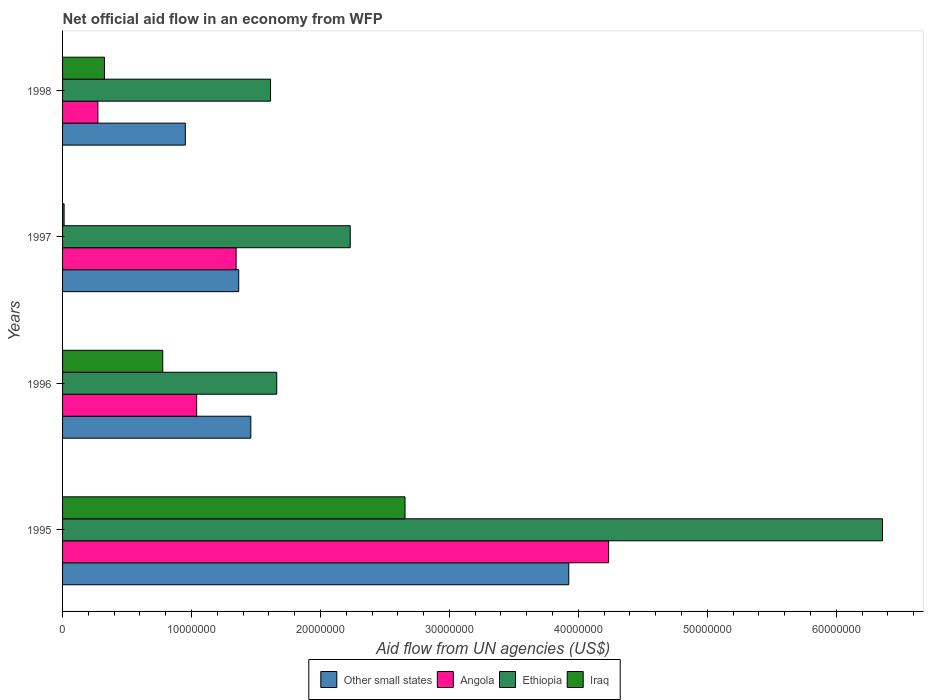How many different coloured bars are there?
Offer a terse response. 4. How many groups of bars are there?
Your answer should be very brief. 4. How many bars are there on the 2nd tick from the bottom?
Keep it short and to the point. 4. What is the label of the 2nd group of bars from the top?
Your answer should be very brief. 1997. What is the net official aid flow in Angola in 1997?
Offer a very short reply. 1.35e+07. Across all years, what is the maximum net official aid flow in Iraq?
Offer a very short reply. 2.66e+07. Across all years, what is the minimum net official aid flow in Angola?
Offer a very short reply. 2.74e+06. In which year was the net official aid flow in Other small states minimum?
Your response must be concise. 1998. What is the total net official aid flow in Iraq in the graph?
Keep it short and to the point. 3.77e+07. What is the difference between the net official aid flow in Angola in 1996 and that in 1998?
Provide a short and direct response. 7.66e+06. What is the difference between the net official aid flow in Ethiopia in 1996 and the net official aid flow in Other small states in 1998?
Provide a short and direct response. 7.09e+06. What is the average net official aid flow in Ethiopia per year?
Offer a very short reply. 2.97e+07. In the year 1996, what is the difference between the net official aid flow in Iraq and net official aid flow in Angola?
Keep it short and to the point. -2.63e+06. In how many years, is the net official aid flow in Other small states greater than 62000000 US$?
Offer a very short reply. 0. What is the ratio of the net official aid flow in Angola in 1996 to that in 1997?
Your answer should be very brief. 0.77. Is the difference between the net official aid flow in Iraq in 1995 and 1997 greater than the difference between the net official aid flow in Angola in 1995 and 1997?
Provide a short and direct response. No. What is the difference between the highest and the second highest net official aid flow in Ethiopia?
Ensure brevity in your answer.  4.13e+07. What is the difference between the highest and the lowest net official aid flow in Iraq?
Keep it short and to the point. 2.64e+07. In how many years, is the net official aid flow in Ethiopia greater than the average net official aid flow in Ethiopia taken over all years?
Your response must be concise. 1. Is the sum of the net official aid flow in Iraq in 1996 and 1998 greater than the maximum net official aid flow in Ethiopia across all years?
Keep it short and to the point. No. What does the 1st bar from the top in 1995 represents?
Provide a succinct answer. Iraq. What does the 2nd bar from the bottom in 1996 represents?
Your answer should be compact. Angola. Is it the case that in every year, the sum of the net official aid flow in Other small states and net official aid flow in Angola is greater than the net official aid flow in Iraq?
Offer a very short reply. Yes. How many bars are there?
Ensure brevity in your answer.  16. Are all the bars in the graph horizontal?
Offer a very short reply. Yes. Are the values on the major ticks of X-axis written in scientific E-notation?
Keep it short and to the point. No. How are the legend labels stacked?
Keep it short and to the point. Horizontal. What is the title of the graph?
Provide a succinct answer. Net official aid flow in an economy from WFP. Does "Middle East & North Africa (all income levels)" appear as one of the legend labels in the graph?
Offer a terse response. No. What is the label or title of the X-axis?
Your answer should be very brief. Aid flow from UN agencies (US$). What is the label or title of the Y-axis?
Offer a terse response. Years. What is the Aid flow from UN agencies (US$) of Other small states in 1995?
Offer a very short reply. 3.93e+07. What is the Aid flow from UN agencies (US$) of Angola in 1995?
Offer a terse response. 4.24e+07. What is the Aid flow from UN agencies (US$) in Ethiopia in 1995?
Provide a short and direct response. 6.36e+07. What is the Aid flow from UN agencies (US$) in Iraq in 1995?
Offer a very short reply. 2.66e+07. What is the Aid flow from UN agencies (US$) of Other small states in 1996?
Your answer should be very brief. 1.46e+07. What is the Aid flow from UN agencies (US$) in Angola in 1996?
Provide a short and direct response. 1.04e+07. What is the Aid flow from UN agencies (US$) in Ethiopia in 1996?
Provide a succinct answer. 1.66e+07. What is the Aid flow from UN agencies (US$) of Iraq in 1996?
Your answer should be very brief. 7.77e+06. What is the Aid flow from UN agencies (US$) in Other small states in 1997?
Offer a terse response. 1.37e+07. What is the Aid flow from UN agencies (US$) of Angola in 1997?
Provide a succinct answer. 1.35e+07. What is the Aid flow from UN agencies (US$) in Ethiopia in 1997?
Keep it short and to the point. 2.23e+07. What is the Aid flow from UN agencies (US$) of Other small states in 1998?
Your response must be concise. 9.52e+06. What is the Aid flow from UN agencies (US$) of Angola in 1998?
Provide a short and direct response. 2.74e+06. What is the Aid flow from UN agencies (US$) in Ethiopia in 1998?
Make the answer very short. 1.61e+07. What is the Aid flow from UN agencies (US$) of Iraq in 1998?
Your response must be concise. 3.25e+06. Across all years, what is the maximum Aid flow from UN agencies (US$) of Other small states?
Your answer should be very brief. 3.93e+07. Across all years, what is the maximum Aid flow from UN agencies (US$) of Angola?
Give a very brief answer. 4.24e+07. Across all years, what is the maximum Aid flow from UN agencies (US$) of Ethiopia?
Offer a terse response. 6.36e+07. Across all years, what is the maximum Aid flow from UN agencies (US$) of Iraq?
Ensure brevity in your answer.  2.66e+07. Across all years, what is the minimum Aid flow from UN agencies (US$) in Other small states?
Keep it short and to the point. 9.52e+06. Across all years, what is the minimum Aid flow from UN agencies (US$) of Angola?
Give a very brief answer. 2.74e+06. Across all years, what is the minimum Aid flow from UN agencies (US$) of Ethiopia?
Give a very brief answer. 1.61e+07. Across all years, what is the minimum Aid flow from UN agencies (US$) in Iraq?
Ensure brevity in your answer.  1.20e+05. What is the total Aid flow from UN agencies (US$) in Other small states in the graph?
Provide a succinct answer. 7.70e+07. What is the total Aid flow from UN agencies (US$) in Angola in the graph?
Make the answer very short. 6.90e+07. What is the total Aid flow from UN agencies (US$) in Ethiopia in the graph?
Keep it short and to the point. 1.19e+08. What is the total Aid flow from UN agencies (US$) in Iraq in the graph?
Provide a succinct answer. 3.77e+07. What is the difference between the Aid flow from UN agencies (US$) in Other small states in 1995 and that in 1996?
Offer a terse response. 2.47e+07. What is the difference between the Aid flow from UN agencies (US$) in Angola in 1995 and that in 1996?
Make the answer very short. 3.20e+07. What is the difference between the Aid flow from UN agencies (US$) in Ethiopia in 1995 and that in 1996?
Your answer should be compact. 4.70e+07. What is the difference between the Aid flow from UN agencies (US$) of Iraq in 1995 and that in 1996?
Ensure brevity in your answer.  1.88e+07. What is the difference between the Aid flow from UN agencies (US$) of Other small states in 1995 and that in 1997?
Provide a short and direct response. 2.56e+07. What is the difference between the Aid flow from UN agencies (US$) in Angola in 1995 and that in 1997?
Provide a succinct answer. 2.89e+07. What is the difference between the Aid flow from UN agencies (US$) in Ethiopia in 1995 and that in 1997?
Provide a succinct answer. 4.13e+07. What is the difference between the Aid flow from UN agencies (US$) in Iraq in 1995 and that in 1997?
Your answer should be compact. 2.64e+07. What is the difference between the Aid flow from UN agencies (US$) in Other small states in 1995 and that in 1998?
Give a very brief answer. 2.97e+07. What is the difference between the Aid flow from UN agencies (US$) in Angola in 1995 and that in 1998?
Ensure brevity in your answer.  3.96e+07. What is the difference between the Aid flow from UN agencies (US$) of Ethiopia in 1995 and that in 1998?
Your answer should be compact. 4.75e+07. What is the difference between the Aid flow from UN agencies (US$) of Iraq in 1995 and that in 1998?
Make the answer very short. 2.33e+07. What is the difference between the Aid flow from UN agencies (US$) of Other small states in 1996 and that in 1997?
Provide a succinct answer. 9.40e+05. What is the difference between the Aid flow from UN agencies (US$) of Angola in 1996 and that in 1997?
Offer a very short reply. -3.06e+06. What is the difference between the Aid flow from UN agencies (US$) of Ethiopia in 1996 and that in 1997?
Provide a succinct answer. -5.70e+06. What is the difference between the Aid flow from UN agencies (US$) of Iraq in 1996 and that in 1997?
Provide a succinct answer. 7.65e+06. What is the difference between the Aid flow from UN agencies (US$) of Other small states in 1996 and that in 1998?
Make the answer very short. 5.08e+06. What is the difference between the Aid flow from UN agencies (US$) of Angola in 1996 and that in 1998?
Make the answer very short. 7.66e+06. What is the difference between the Aid flow from UN agencies (US$) of Ethiopia in 1996 and that in 1998?
Offer a very short reply. 4.80e+05. What is the difference between the Aid flow from UN agencies (US$) in Iraq in 1996 and that in 1998?
Offer a terse response. 4.52e+06. What is the difference between the Aid flow from UN agencies (US$) of Other small states in 1997 and that in 1998?
Your response must be concise. 4.14e+06. What is the difference between the Aid flow from UN agencies (US$) of Angola in 1997 and that in 1998?
Ensure brevity in your answer.  1.07e+07. What is the difference between the Aid flow from UN agencies (US$) of Ethiopia in 1997 and that in 1998?
Offer a terse response. 6.18e+06. What is the difference between the Aid flow from UN agencies (US$) in Iraq in 1997 and that in 1998?
Provide a succinct answer. -3.13e+06. What is the difference between the Aid flow from UN agencies (US$) of Other small states in 1995 and the Aid flow from UN agencies (US$) of Angola in 1996?
Your answer should be compact. 2.89e+07. What is the difference between the Aid flow from UN agencies (US$) of Other small states in 1995 and the Aid flow from UN agencies (US$) of Ethiopia in 1996?
Your answer should be compact. 2.26e+07. What is the difference between the Aid flow from UN agencies (US$) of Other small states in 1995 and the Aid flow from UN agencies (US$) of Iraq in 1996?
Give a very brief answer. 3.15e+07. What is the difference between the Aid flow from UN agencies (US$) in Angola in 1995 and the Aid flow from UN agencies (US$) in Ethiopia in 1996?
Your response must be concise. 2.57e+07. What is the difference between the Aid flow from UN agencies (US$) in Angola in 1995 and the Aid flow from UN agencies (US$) in Iraq in 1996?
Provide a succinct answer. 3.46e+07. What is the difference between the Aid flow from UN agencies (US$) of Ethiopia in 1995 and the Aid flow from UN agencies (US$) of Iraq in 1996?
Offer a very short reply. 5.58e+07. What is the difference between the Aid flow from UN agencies (US$) of Other small states in 1995 and the Aid flow from UN agencies (US$) of Angola in 1997?
Offer a very short reply. 2.58e+07. What is the difference between the Aid flow from UN agencies (US$) in Other small states in 1995 and the Aid flow from UN agencies (US$) in Ethiopia in 1997?
Your response must be concise. 1.70e+07. What is the difference between the Aid flow from UN agencies (US$) of Other small states in 1995 and the Aid flow from UN agencies (US$) of Iraq in 1997?
Offer a very short reply. 3.91e+07. What is the difference between the Aid flow from UN agencies (US$) in Angola in 1995 and the Aid flow from UN agencies (US$) in Ethiopia in 1997?
Make the answer very short. 2.00e+07. What is the difference between the Aid flow from UN agencies (US$) in Angola in 1995 and the Aid flow from UN agencies (US$) in Iraq in 1997?
Offer a very short reply. 4.22e+07. What is the difference between the Aid flow from UN agencies (US$) in Ethiopia in 1995 and the Aid flow from UN agencies (US$) in Iraq in 1997?
Provide a succinct answer. 6.35e+07. What is the difference between the Aid flow from UN agencies (US$) in Other small states in 1995 and the Aid flow from UN agencies (US$) in Angola in 1998?
Offer a very short reply. 3.65e+07. What is the difference between the Aid flow from UN agencies (US$) in Other small states in 1995 and the Aid flow from UN agencies (US$) in Ethiopia in 1998?
Give a very brief answer. 2.31e+07. What is the difference between the Aid flow from UN agencies (US$) in Other small states in 1995 and the Aid flow from UN agencies (US$) in Iraq in 1998?
Make the answer very short. 3.60e+07. What is the difference between the Aid flow from UN agencies (US$) of Angola in 1995 and the Aid flow from UN agencies (US$) of Ethiopia in 1998?
Provide a short and direct response. 2.62e+07. What is the difference between the Aid flow from UN agencies (US$) of Angola in 1995 and the Aid flow from UN agencies (US$) of Iraq in 1998?
Your answer should be compact. 3.91e+07. What is the difference between the Aid flow from UN agencies (US$) in Ethiopia in 1995 and the Aid flow from UN agencies (US$) in Iraq in 1998?
Ensure brevity in your answer.  6.03e+07. What is the difference between the Aid flow from UN agencies (US$) of Other small states in 1996 and the Aid flow from UN agencies (US$) of Angola in 1997?
Ensure brevity in your answer.  1.14e+06. What is the difference between the Aid flow from UN agencies (US$) of Other small states in 1996 and the Aid flow from UN agencies (US$) of Ethiopia in 1997?
Keep it short and to the point. -7.71e+06. What is the difference between the Aid flow from UN agencies (US$) in Other small states in 1996 and the Aid flow from UN agencies (US$) in Iraq in 1997?
Ensure brevity in your answer.  1.45e+07. What is the difference between the Aid flow from UN agencies (US$) in Angola in 1996 and the Aid flow from UN agencies (US$) in Ethiopia in 1997?
Make the answer very short. -1.19e+07. What is the difference between the Aid flow from UN agencies (US$) of Angola in 1996 and the Aid flow from UN agencies (US$) of Iraq in 1997?
Provide a succinct answer. 1.03e+07. What is the difference between the Aid flow from UN agencies (US$) of Ethiopia in 1996 and the Aid flow from UN agencies (US$) of Iraq in 1997?
Your response must be concise. 1.65e+07. What is the difference between the Aid flow from UN agencies (US$) in Other small states in 1996 and the Aid flow from UN agencies (US$) in Angola in 1998?
Give a very brief answer. 1.19e+07. What is the difference between the Aid flow from UN agencies (US$) of Other small states in 1996 and the Aid flow from UN agencies (US$) of Ethiopia in 1998?
Your response must be concise. -1.53e+06. What is the difference between the Aid flow from UN agencies (US$) in Other small states in 1996 and the Aid flow from UN agencies (US$) in Iraq in 1998?
Provide a short and direct response. 1.14e+07. What is the difference between the Aid flow from UN agencies (US$) of Angola in 1996 and the Aid flow from UN agencies (US$) of Ethiopia in 1998?
Your answer should be compact. -5.73e+06. What is the difference between the Aid flow from UN agencies (US$) of Angola in 1996 and the Aid flow from UN agencies (US$) of Iraq in 1998?
Offer a very short reply. 7.15e+06. What is the difference between the Aid flow from UN agencies (US$) in Ethiopia in 1996 and the Aid flow from UN agencies (US$) in Iraq in 1998?
Ensure brevity in your answer.  1.34e+07. What is the difference between the Aid flow from UN agencies (US$) of Other small states in 1997 and the Aid flow from UN agencies (US$) of Angola in 1998?
Give a very brief answer. 1.09e+07. What is the difference between the Aid flow from UN agencies (US$) in Other small states in 1997 and the Aid flow from UN agencies (US$) in Ethiopia in 1998?
Your answer should be compact. -2.47e+06. What is the difference between the Aid flow from UN agencies (US$) of Other small states in 1997 and the Aid flow from UN agencies (US$) of Iraq in 1998?
Make the answer very short. 1.04e+07. What is the difference between the Aid flow from UN agencies (US$) in Angola in 1997 and the Aid flow from UN agencies (US$) in Ethiopia in 1998?
Make the answer very short. -2.67e+06. What is the difference between the Aid flow from UN agencies (US$) of Angola in 1997 and the Aid flow from UN agencies (US$) of Iraq in 1998?
Your response must be concise. 1.02e+07. What is the difference between the Aid flow from UN agencies (US$) in Ethiopia in 1997 and the Aid flow from UN agencies (US$) in Iraq in 1998?
Your answer should be very brief. 1.91e+07. What is the average Aid flow from UN agencies (US$) in Other small states per year?
Ensure brevity in your answer.  1.93e+07. What is the average Aid flow from UN agencies (US$) in Angola per year?
Provide a succinct answer. 1.72e+07. What is the average Aid flow from UN agencies (US$) in Ethiopia per year?
Your response must be concise. 2.97e+07. What is the average Aid flow from UN agencies (US$) of Iraq per year?
Ensure brevity in your answer.  9.42e+06. In the year 1995, what is the difference between the Aid flow from UN agencies (US$) of Other small states and Aid flow from UN agencies (US$) of Angola?
Offer a very short reply. -3.09e+06. In the year 1995, what is the difference between the Aid flow from UN agencies (US$) of Other small states and Aid flow from UN agencies (US$) of Ethiopia?
Offer a very short reply. -2.43e+07. In the year 1995, what is the difference between the Aid flow from UN agencies (US$) in Other small states and Aid flow from UN agencies (US$) in Iraq?
Keep it short and to the point. 1.27e+07. In the year 1995, what is the difference between the Aid flow from UN agencies (US$) in Angola and Aid flow from UN agencies (US$) in Ethiopia?
Give a very brief answer. -2.12e+07. In the year 1995, what is the difference between the Aid flow from UN agencies (US$) in Angola and Aid flow from UN agencies (US$) in Iraq?
Your answer should be very brief. 1.58e+07. In the year 1995, what is the difference between the Aid flow from UN agencies (US$) in Ethiopia and Aid flow from UN agencies (US$) in Iraq?
Provide a succinct answer. 3.70e+07. In the year 1996, what is the difference between the Aid flow from UN agencies (US$) in Other small states and Aid flow from UN agencies (US$) in Angola?
Ensure brevity in your answer.  4.20e+06. In the year 1996, what is the difference between the Aid flow from UN agencies (US$) in Other small states and Aid flow from UN agencies (US$) in Ethiopia?
Give a very brief answer. -2.01e+06. In the year 1996, what is the difference between the Aid flow from UN agencies (US$) of Other small states and Aid flow from UN agencies (US$) of Iraq?
Keep it short and to the point. 6.83e+06. In the year 1996, what is the difference between the Aid flow from UN agencies (US$) in Angola and Aid flow from UN agencies (US$) in Ethiopia?
Make the answer very short. -6.21e+06. In the year 1996, what is the difference between the Aid flow from UN agencies (US$) in Angola and Aid flow from UN agencies (US$) in Iraq?
Your response must be concise. 2.63e+06. In the year 1996, what is the difference between the Aid flow from UN agencies (US$) in Ethiopia and Aid flow from UN agencies (US$) in Iraq?
Provide a succinct answer. 8.84e+06. In the year 1997, what is the difference between the Aid flow from UN agencies (US$) of Other small states and Aid flow from UN agencies (US$) of Angola?
Make the answer very short. 2.00e+05. In the year 1997, what is the difference between the Aid flow from UN agencies (US$) in Other small states and Aid flow from UN agencies (US$) in Ethiopia?
Offer a very short reply. -8.65e+06. In the year 1997, what is the difference between the Aid flow from UN agencies (US$) of Other small states and Aid flow from UN agencies (US$) of Iraq?
Provide a succinct answer. 1.35e+07. In the year 1997, what is the difference between the Aid flow from UN agencies (US$) of Angola and Aid flow from UN agencies (US$) of Ethiopia?
Offer a very short reply. -8.85e+06. In the year 1997, what is the difference between the Aid flow from UN agencies (US$) of Angola and Aid flow from UN agencies (US$) of Iraq?
Your answer should be very brief. 1.33e+07. In the year 1997, what is the difference between the Aid flow from UN agencies (US$) of Ethiopia and Aid flow from UN agencies (US$) of Iraq?
Ensure brevity in your answer.  2.22e+07. In the year 1998, what is the difference between the Aid flow from UN agencies (US$) of Other small states and Aid flow from UN agencies (US$) of Angola?
Keep it short and to the point. 6.78e+06. In the year 1998, what is the difference between the Aid flow from UN agencies (US$) of Other small states and Aid flow from UN agencies (US$) of Ethiopia?
Ensure brevity in your answer.  -6.61e+06. In the year 1998, what is the difference between the Aid flow from UN agencies (US$) in Other small states and Aid flow from UN agencies (US$) in Iraq?
Keep it short and to the point. 6.27e+06. In the year 1998, what is the difference between the Aid flow from UN agencies (US$) in Angola and Aid flow from UN agencies (US$) in Ethiopia?
Your response must be concise. -1.34e+07. In the year 1998, what is the difference between the Aid flow from UN agencies (US$) in Angola and Aid flow from UN agencies (US$) in Iraq?
Provide a short and direct response. -5.10e+05. In the year 1998, what is the difference between the Aid flow from UN agencies (US$) in Ethiopia and Aid flow from UN agencies (US$) in Iraq?
Provide a short and direct response. 1.29e+07. What is the ratio of the Aid flow from UN agencies (US$) of Other small states in 1995 to that in 1996?
Give a very brief answer. 2.69. What is the ratio of the Aid flow from UN agencies (US$) of Angola in 1995 to that in 1996?
Offer a very short reply. 4.07. What is the ratio of the Aid flow from UN agencies (US$) in Ethiopia in 1995 to that in 1996?
Provide a short and direct response. 3.83. What is the ratio of the Aid flow from UN agencies (US$) in Iraq in 1995 to that in 1996?
Your answer should be very brief. 3.42. What is the ratio of the Aid flow from UN agencies (US$) in Other small states in 1995 to that in 1997?
Provide a succinct answer. 2.87. What is the ratio of the Aid flow from UN agencies (US$) in Angola in 1995 to that in 1997?
Provide a succinct answer. 3.15. What is the ratio of the Aid flow from UN agencies (US$) of Ethiopia in 1995 to that in 1997?
Give a very brief answer. 2.85. What is the ratio of the Aid flow from UN agencies (US$) of Iraq in 1995 to that in 1997?
Offer a terse response. 221.33. What is the ratio of the Aid flow from UN agencies (US$) of Other small states in 1995 to that in 1998?
Offer a very short reply. 4.12. What is the ratio of the Aid flow from UN agencies (US$) in Angola in 1995 to that in 1998?
Ensure brevity in your answer.  15.46. What is the ratio of the Aid flow from UN agencies (US$) in Ethiopia in 1995 to that in 1998?
Give a very brief answer. 3.94. What is the ratio of the Aid flow from UN agencies (US$) of Iraq in 1995 to that in 1998?
Provide a succinct answer. 8.17. What is the ratio of the Aid flow from UN agencies (US$) in Other small states in 1996 to that in 1997?
Give a very brief answer. 1.07. What is the ratio of the Aid flow from UN agencies (US$) of Angola in 1996 to that in 1997?
Make the answer very short. 0.77. What is the ratio of the Aid flow from UN agencies (US$) in Ethiopia in 1996 to that in 1997?
Keep it short and to the point. 0.74. What is the ratio of the Aid flow from UN agencies (US$) in Iraq in 1996 to that in 1997?
Provide a short and direct response. 64.75. What is the ratio of the Aid flow from UN agencies (US$) in Other small states in 1996 to that in 1998?
Make the answer very short. 1.53. What is the ratio of the Aid flow from UN agencies (US$) of Angola in 1996 to that in 1998?
Provide a short and direct response. 3.8. What is the ratio of the Aid flow from UN agencies (US$) of Ethiopia in 1996 to that in 1998?
Your answer should be very brief. 1.03. What is the ratio of the Aid flow from UN agencies (US$) of Iraq in 1996 to that in 1998?
Your answer should be very brief. 2.39. What is the ratio of the Aid flow from UN agencies (US$) of Other small states in 1997 to that in 1998?
Provide a short and direct response. 1.43. What is the ratio of the Aid flow from UN agencies (US$) of Angola in 1997 to that in 1998?
Offer a terse response. 4.91. What is the ratio of the Aid flow from UN agencies (US$) in Ethiopia in 1997 to that in 1998?
Ensure brevity in your answer.  1.38. What is the ratio of the Aid flow from UN agencies (US$) of Iraq in 1997 to that in 1998?
Make the answer very short. 0.04. What is the difference between the highest and the second highest Aid flow from UN agencies (US$) in Other small states?
Give a very brief answer. 2.47e+07. What is the difference between the highest and the second highest Aid flow from UN agencies (US$) in Angola?
Make the answer very short. 2.89e+07. What is the difference between the highest and the second highest Aid flow from UN agencies (US$) of Ethiopia?
Keep it short and to the point. 4.13e+07. What is the difference between the highest and the second highest Aid flow from UN agencies (US$) in Iraq?
Keep it short and to the point. 1.88e+07. What is the difference between the highest and the lowest Aid flow from UN agencies (US$) in Other small states?
Your answer should be compact. 2.97e+07. What is the difference between the highest and the lowest Aid flow from UN agencies (US$) in Angola?
Provide a succinct answer. 3.96e+07. What is the difference between the highest and the lowest Aid flow from UN agencies (US$) in Ethiopia?
Provide a short and direct response. 4.75e+07. What is the difference between the highest and the lowest Aid flow from UN agencies (US$) of Iraq?
Offer a terse response. 2.64e+07. 